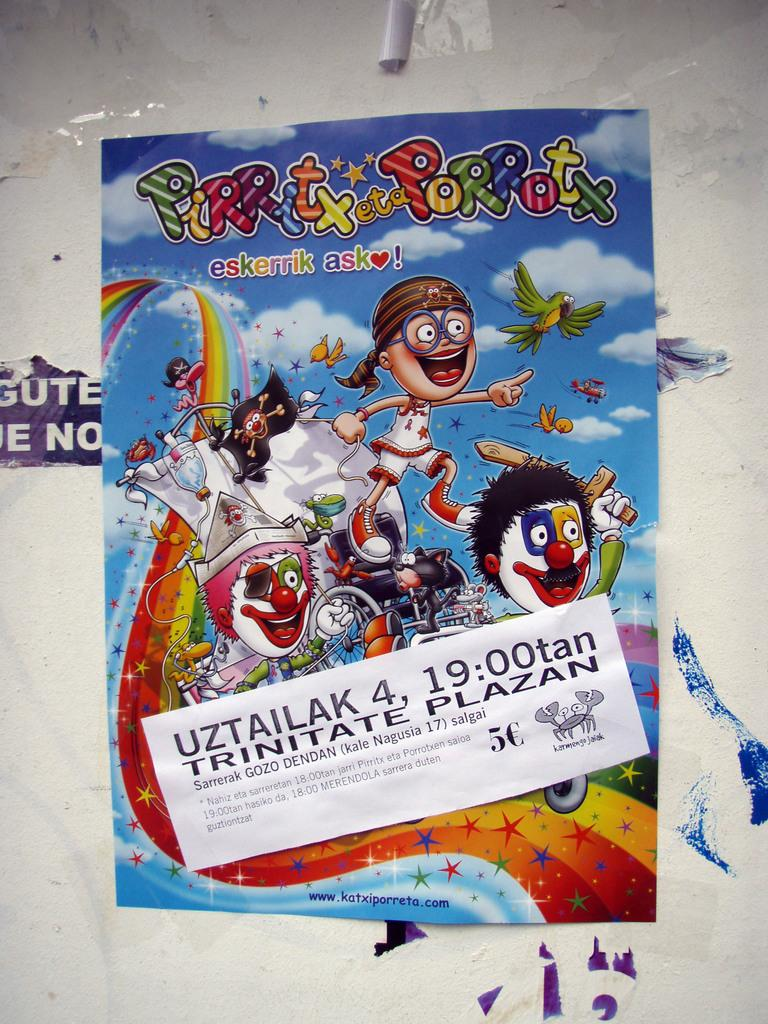Provide a one-sentence caption for the provided image. A poster for a cartoon has the words Pirritx eta Porrotx on it. 